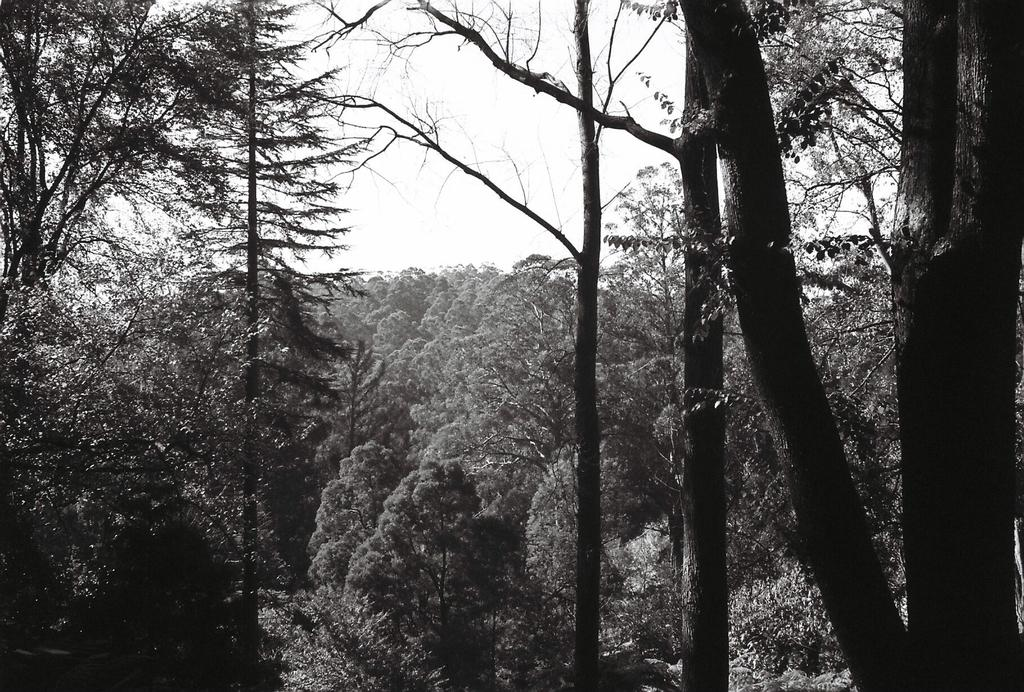What type of vegetation can be seen in the image? There are trees in the image. Are there any lead pipes visible in the image? There is no mention of lead pipes or any other man-made structures in the image; it only features trees. Can you see any tubs or bathtubs in the image? There is no mention of tubs or bathtubs in the image; it only features trees. 